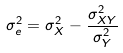<formula> <loc_0><loc_0><loc_500><loc_500>\sigma _ { e } ^ { 2 } = \sigma _ { X } ^ { 2 } - \frac { \sigma _ { X Y } ^ { 2 } } { \sigma _ { Y } ^ { 2 } }</formula> 